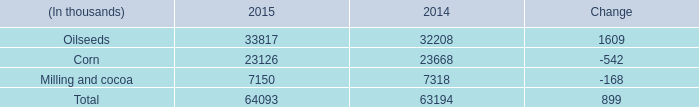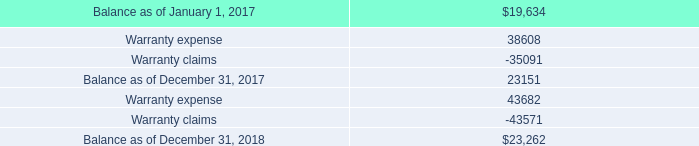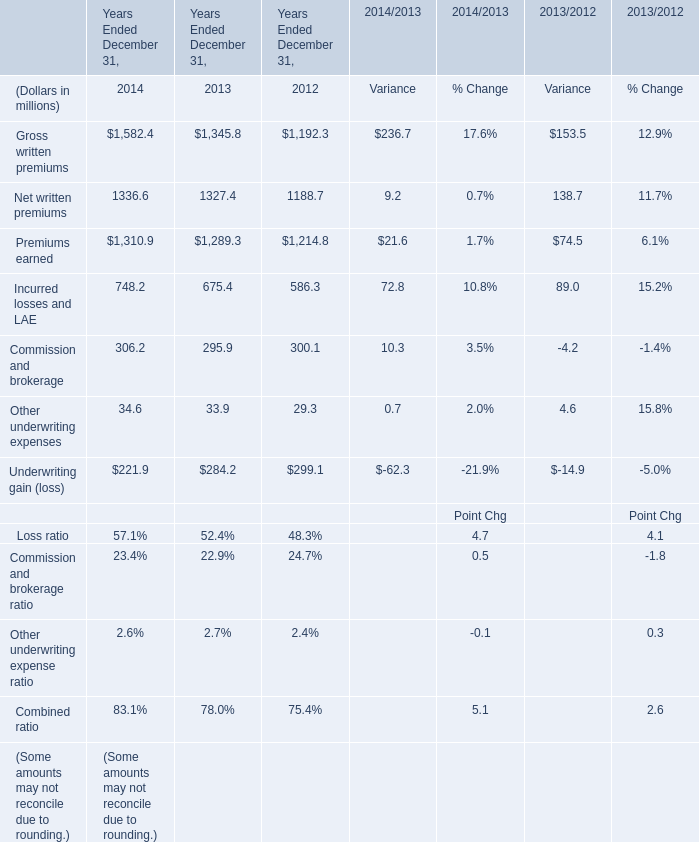What's the average of Balance as of December 31, 2017, and Premiums earned of Years Ended December 31, 2013 ? 
Computations: ((23151.0 + 1289.3) / 2)
Answer: 12220.15. 